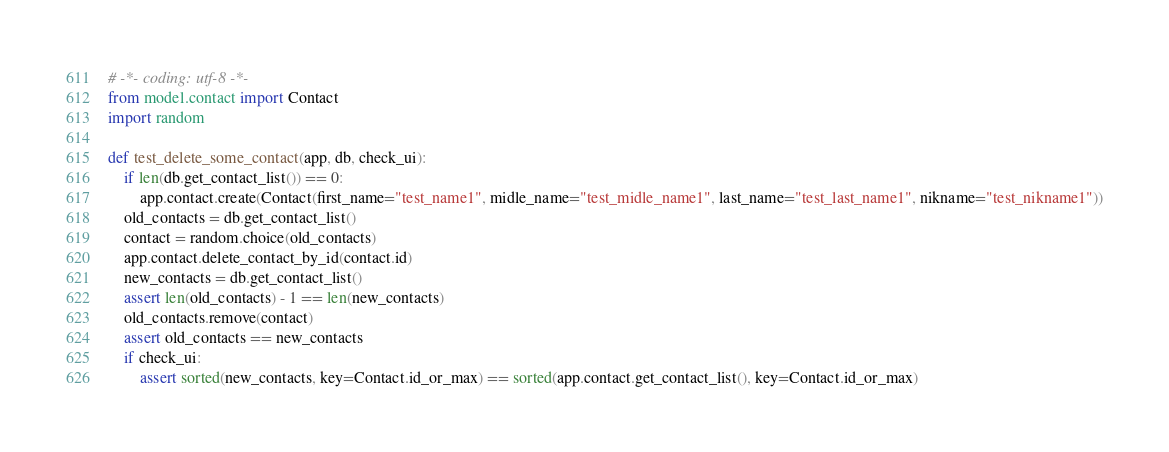<code> <loc_0><loc_0><loc_500><loc_500><_Python_># -*- coding: utf-8 -*-
from model.contact import Contact
import random

def test_delete_some_contact(app, db, check_ui):
    if len(db.get_contact_list()) == 0:
        app.contact.create(Contact(first_name="test_name1", midle_name="test_midle_name1", last_name="test_last_name1", nikname="test_nikname1"))
    old_contacts = db.get_contact_list()
    contact = random.choice(old_contacts)
    app.contact.delete_contact_by_id(contact.id)
    new_contacts = db.get_contact_list()
    assert len(old_contacts) - 1 == len(new_contacts)
    old_contacts.remove(contact)
    assert old_contacts == new_contacts
    if check_ui:
        assert sorted(new_contacts, key=Contact.id_or_max) == sorted(app.contact.get_contact_list(), key=Contact.id_or_max)
</code> 